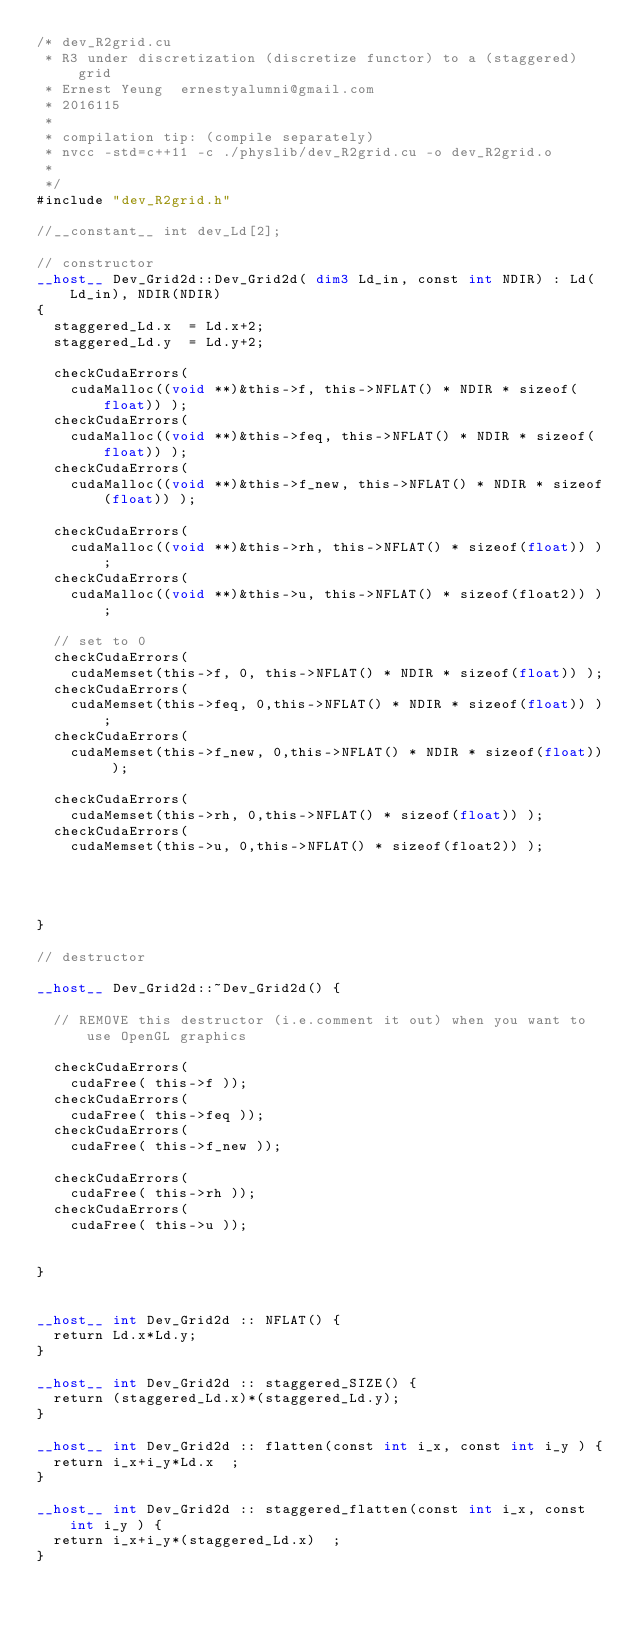Convert code to text. <code><loc_0><loc_0><loc_500><loc_500><_Cuda_>/* dev_R2grid.cu
 * R3 under discretization (discretize functor) to a (staggered) grid
 * Ernest Yeung  ernestyalumni@gmail.com
 * 2016115
 * 
 * compilation tip: (compile separately)
 * nvcc -std=c++11 -c ./physlib/dev_R2grid.cu -o dev_R2grid.o
 * 
 */
#include "dev_R2grid.h"

//__constant__ int dev_Ld[2];

// constructor
__host__ Dev_Grid2d::Dev_Grid2d( dim3 Ld_in, const int NDIR) : Ld(Ld_in), NDIR(NDIR)
{
	staggered_Ld.x  = Ld.x+2;
	staggered_Ld.y  = Ld.y+2;

	checkCudaErrors( 
		cudaMalloc((void **)&this->f, this->NFLAT() * NDIR * sizeof(float)) );
	checkCudaErrors( 
		cudaMalloc((void **)&this->feq, this->NFLAT() * NDIR * sizeof(float)) );
	checkCudaErrors( 
		cudaMalloc((void **)&this->f_new, this->NFLAT() * NDIR * sizeof(float)) );
	
	checkCudaErrors( 
		cudaMalloc((void **)&this->rh, this->NFLAT() * sizeof(float)) );
	checkCudaErrors( 
		cudaMalloc((void **)&this->u, this->NFLAT() * sizeof(float2)) );

	// set to 0
	checkCudaErrors( 
		cudaMemset(this->f, 0, this->NFLAT() * NDIR * sizeof(float)) );
	checkCudaErrors( 
		cudaMemset(this->feq, 0,this->NFLAT() * NDIR * sizeof(float)) );
	checkCudaErrors( 
		cudaMemset(this->f_new, 0,this->NFLAT() * NDIR * sizeof(float)) );

	checkCudaErrors( 
		cudaMemset(this->rh, 0,this->NFLAT() * sizeof(float)) );
	checkCudaErrors( 
		cudaMemset(this->u, 0,this->NFLAT() * sizeof(float2)) );

	
	
	
}

// destructor

__host__ Dev_Grid2d::~Dev_Grid2d() {

	// REMOVE this destructor (i.e.comment it out) when you want to use OpenGL graphics
	
	checkCudaErrors(
		cudaFree( this->f ));
	checkCudaErrors(
		cudaFree( this->feq ));
	checkCudaErrors(
		cudaFree( this->f_new ));

	checkCudaErrors(
		cudaFree( this->rh ));
	checkCudaErrors(
		cudaFree( this->u ));


}


__host__ int Dev_Grid2d :: NFLAT() {
	return Ld.x*Ld.y;
}	

__host__ int Dev_Grid2d :: staggered_SIZE() {
	return (staggered_Ld.x)*(staggered_Ld.y);
}	

__host__ int Dev_Grid2d :: flatten(const int i_x, const int i_y ) {
	return i_x+i_y*Ld.x  ;
}

__host__ int Dev_Grid2d :: staggered_flatten(const int i_x, const int i_y ) {
	return i_x+i_y*(staggered_Ld.x)  ;
}

</code> 